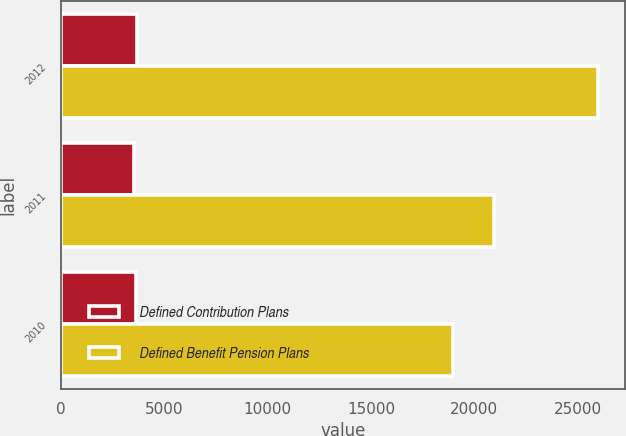Convert chart to OTSL. <chart><loc_0><loc_0><loc_500><loc_500><stacked_bar_chart><ecel><fcel>2012<fcel>2011<fcel>2010<nl><fcel>Defined Contribution Plans<fcel>3668<fcel>3552<fcel>3617<nl><fcel>Defined Benefit Pension Plans<fcel>26007<fcel>20952<fcel>18948<nl></chart> 